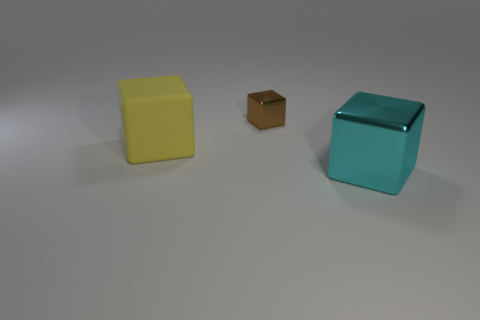Could you describe the lighting and shadows in the scene? Do they suggest anything about the light source? There are soft shadows under each cube, suggesting a diffuse overhead light source, which is typical for studio lighting designed to minimize harsh shadows. Does the image seem to be computer-generated or photographed in a physical environment? Given the perfection of the cubes' edges, the uniformity of their color, and the seamless background, the image appears to be computer-generated rather than captured in a physical setting. 